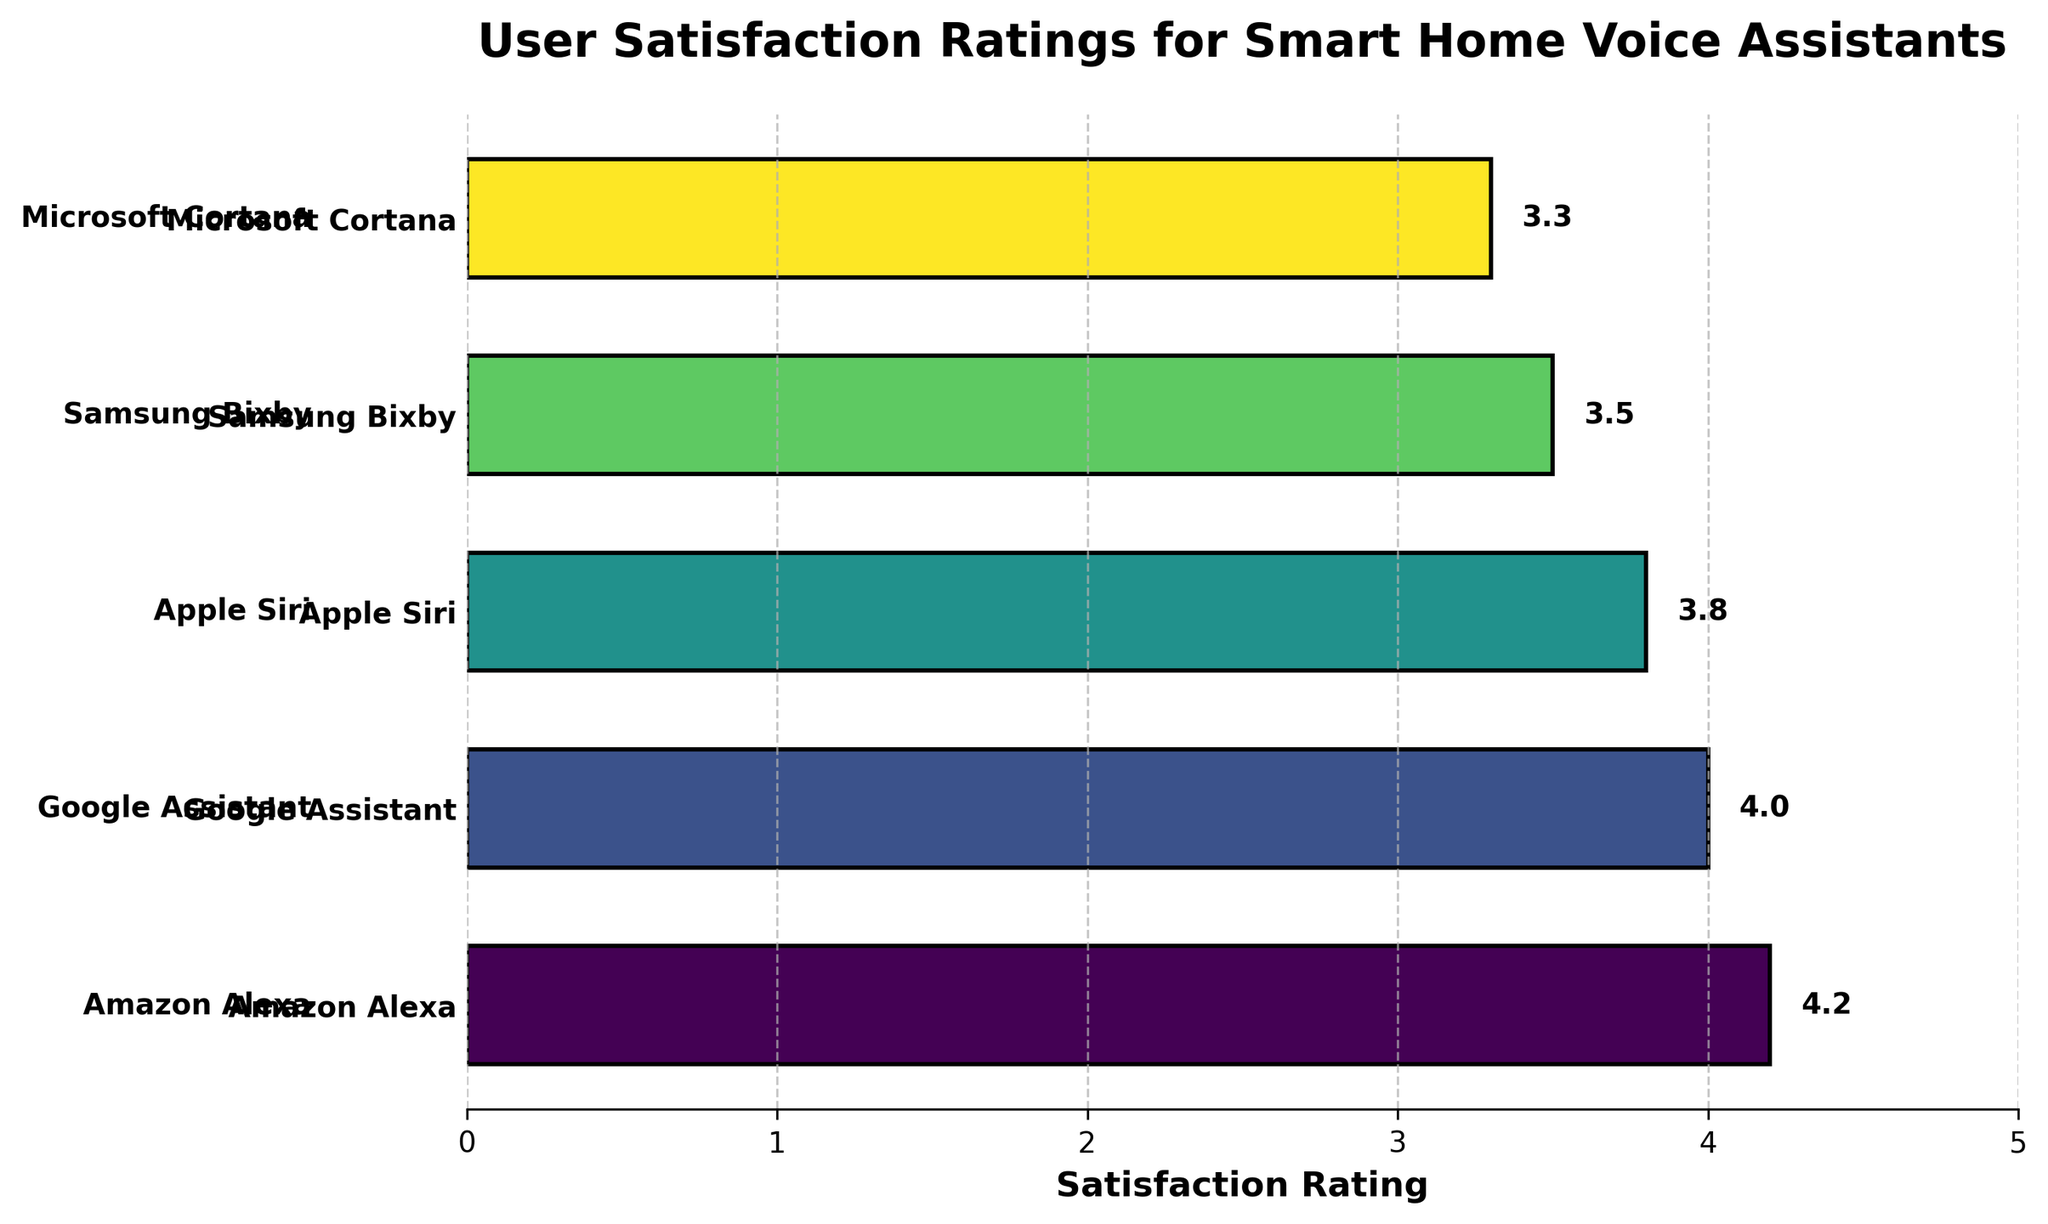Which voice assistant has the highest user satisfaction rating? Look at the plotted bars and identify the longest bar; the longest bar represents the highest rating. Verify the corresponding voice assistant.
Answer: Amazon Alexa What is the user satisfaction rating for Google Assistant? Locate the bar corresponding to Google Assistant and read the numeric value displayed at the end of the bar.
Answer: 4.0 Between Apple Siri and Samsung Bixby, which has a higher satisfaction rating? Compare the lengths of the bars for Apple Siri and Samsung Bixby. The longer bar indicates a higher rating.
Answer: Apple Siri What is the range of user satisfaction ratings for these voice assistants? Find the difference between the highest and lowest satisfaction ratings by subtracting the lowest rating from the highest.
Answer: 0.9 How many voice assistants have a user satisfaction rating below 4.0? Count the number of bars that terminate before the 4.0 mark on the satisfaction rating axis.
Answer: 3 Which voice assistant has the lowest user satisfaction rating? Identify the shortest bar in the plot, which corresponds to the lowest satisfaction rating. Verify the corresponding voice assistant.
Answer: Microsoft Cortana What is the average satisfaction rating of all listed voice assistants? Sum the satisfaction ratings of all voice assistants and divide by the total number of assistants: (4.2 + 4.0 + 3.8 + 3.5 + 3.3) / 5.
Answer: 3.76 What is the difference in satisfaction ratings between Amazon Alexa and Microsoft Cortana? Subtract the satisfaction rating of Microsoft Cortana from that of Amazon Alexa: 4.2 - 3.3.
Answer: 0.9 